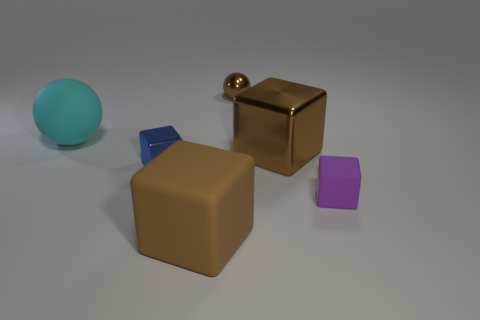There is a blue object that is the same shape as the purple object; what material is it?
Your answer should be very brief. Metal. Do the brown thing to the left of the small metal ball and the brown object that is behind the cyan matte thing have the same shape?
Keep it short and to the point. No. Are there more small yellow metallic things than tiny blue metallic objects?
Provide a short and direct response. No. How big is the purple matte cube?
Ensure brevity in your answer.  Small. What number of other objects are there of the same color as the big sphere?
Provide a succinct answer. 0. Are the ball that is behind the large cyan sphere and the small blue cube made of the same material?
Offer a terse response. Yes. Is the number of small blue shiny objects that are on the left side of the blue metal thing less than the number of purple cubes that are behind the tiny purple block?
Keep it short and to the point. No. What number of other objects are there of the same material as the cyan ball?
Provide a short and direct response. 2. There is a blue object that is the same size as the brown shiny sphere; what material is it?
Your answer should be compact. Metal. Are there fewer purple matte cubes behind the brown rubber thing than purple metallic spheres?
Offer a terse response. No. 